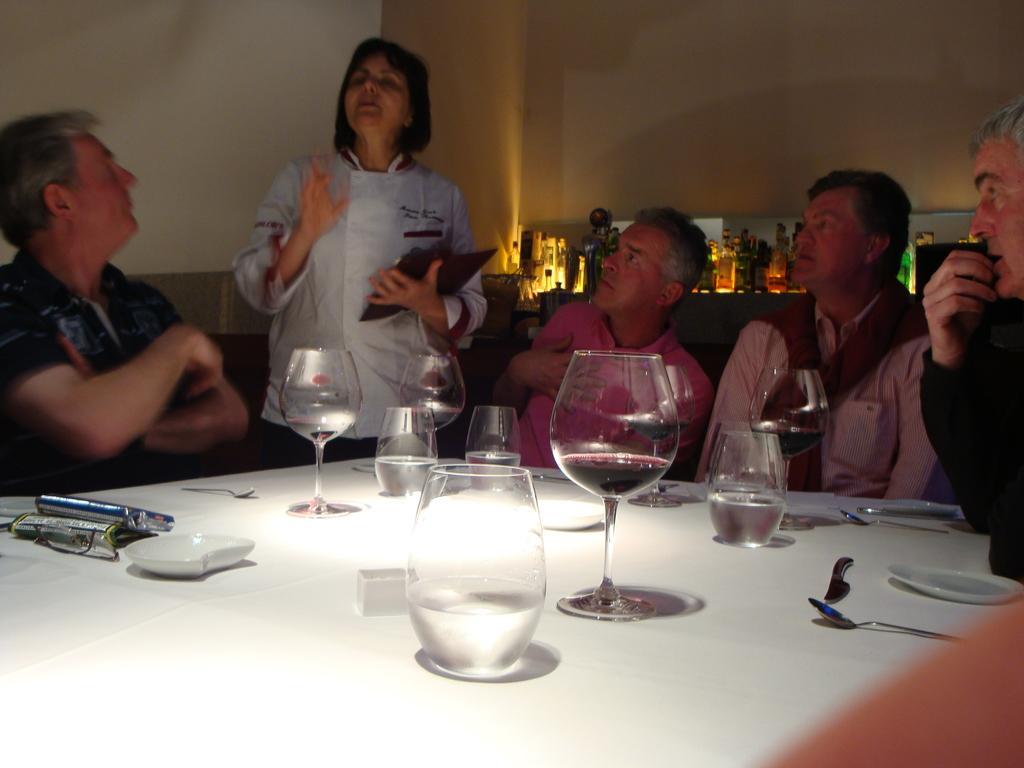Please provide a concise description of this image. Four men are sitting around a table. A woman is taking the order. There are some glasses of water on the table. Some plates,forks and spoons on the table. 